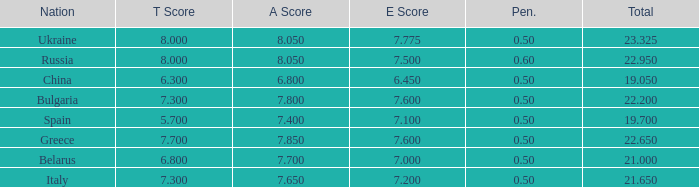What E score has the T score of 8 and a number smaller than 22.95? None. 